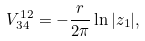Convert formula to latex. <formula><loc_0><loc_0><loc_500><loc_500>V _ { 3 4 } ^ { 1 2 } = - \frac { r } { 2 \pi } \ln | z _ { 1 } | ,</formula> 